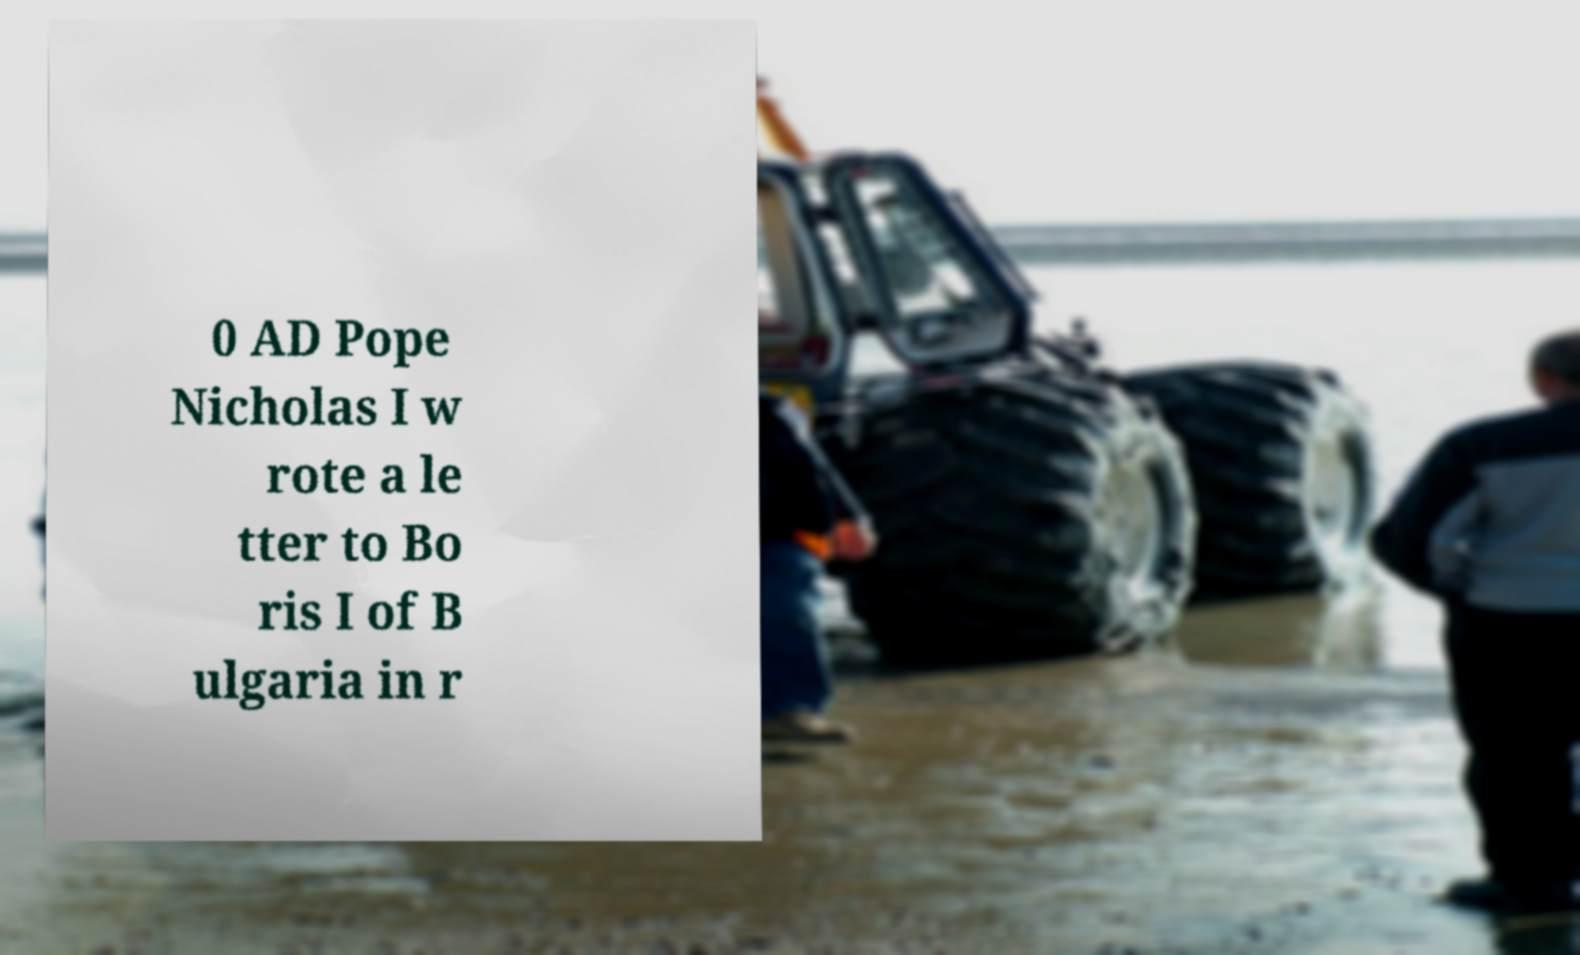There's text embedded in this image that I need extracted. Can you transcribe it verbatim? 0 AD Pope Nicholas I w rote a le tter to Bo ris I of B ulgaria in r 